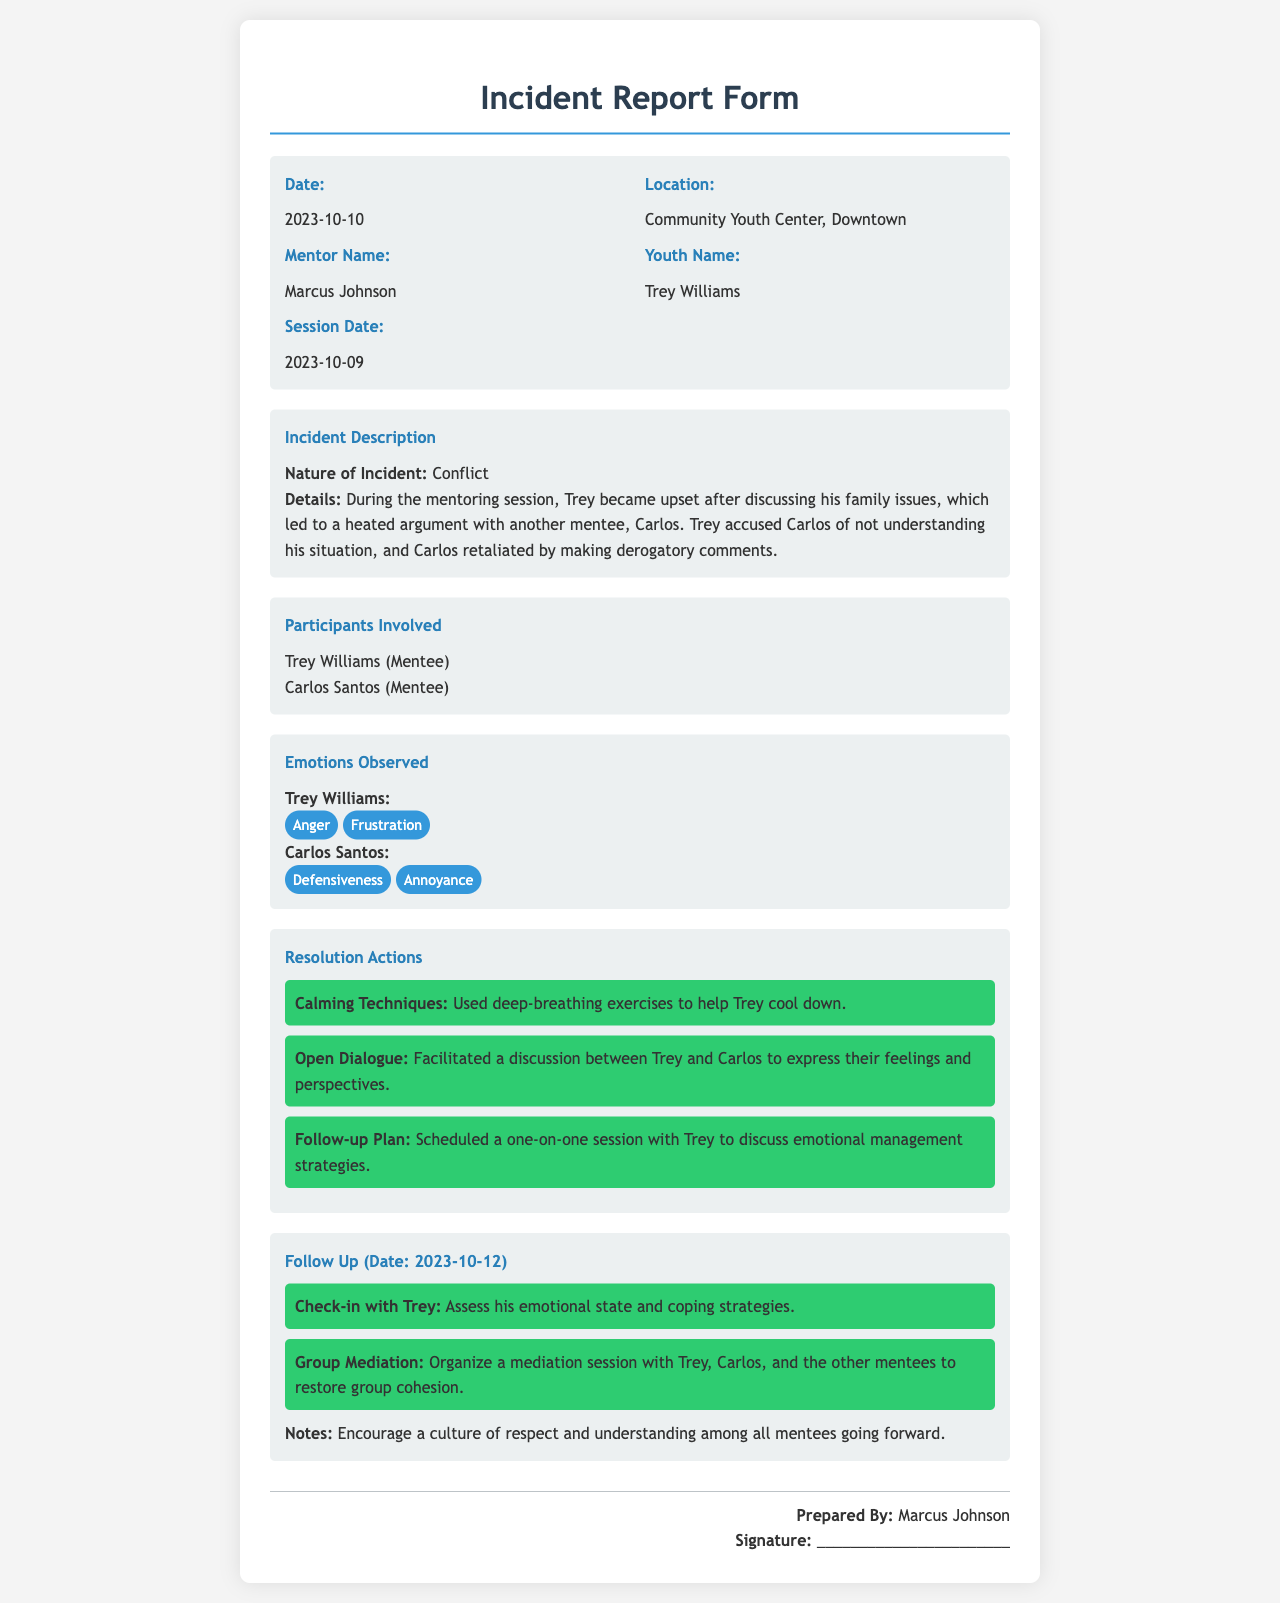What is the date of the incident? The date of the incident is stated in the document.
Answer: 2023-10-10 What is the location of the mentoring session? The location is specified in the document as where the incident took place.
Answer: Community Youth Center, Downtown Who is the mentor named in the report? The report includes the mentor's name who prepared the document.
Answer: Marcus Johnson What was the nature of the incident? The document describes the type of incident that occurred during the session.
Answer: Conflict Which two mentees were involved in the incident? The report lists the names of mentees involved in the conflict.
Answer: Trey Williams, Carlos Santos What emotions did Trey display during the incident? The document provides the specific emotions observed in Trey during the conflict.
Answer: Anger, Frustration What calming technique was used during the conflict? The report outlines a specific method used to help the mentee calm down.
Answer: Deep-breathing exercises What is the date of the follow-up? The document specifies when the follow-up actions will take place.
Answer: 2023-10-12 What follow-up action involves assessing emotional state? The report identifies a specific follow-up action focused on emotion.
Answer: Check-in with Trey 